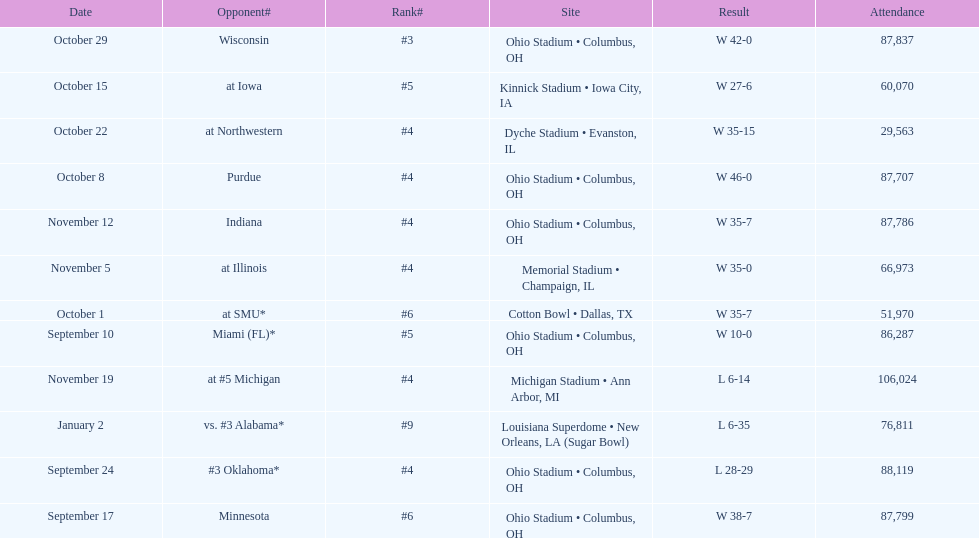How many dates are present on the graph? 12. 